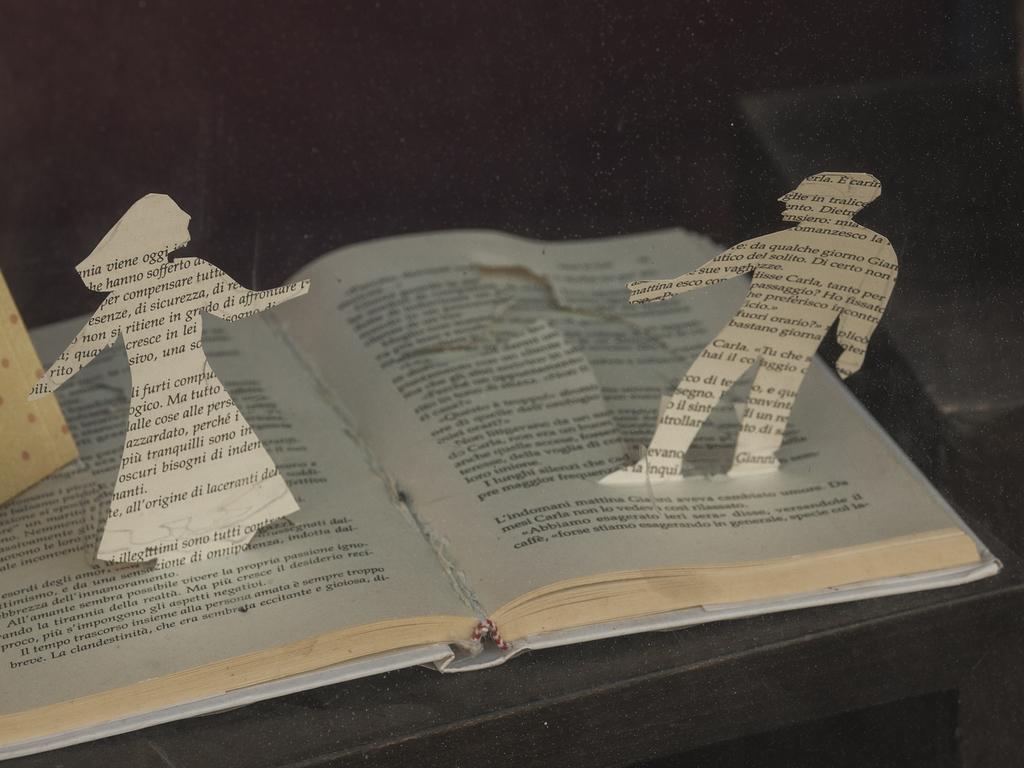What is any word on the page?
Provide a short and direct response. Carla. 